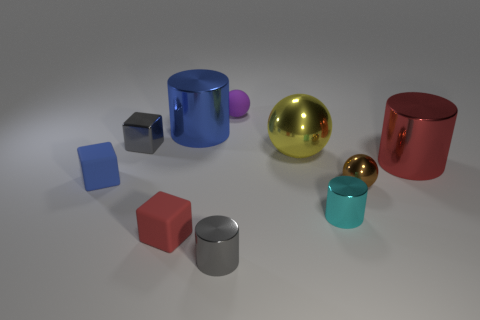Subtract all cubes. How many objects are left? 7 Add 6 tiny purple objects. How many tiny purple objects are left? 7 Add 1 gray things. How many gray things exist? 3 Subtract 1 purple balls. How many objects are left? 9 Subtract all cyan metal things. Subtract all gray cylinders. How many objects are left? 8 